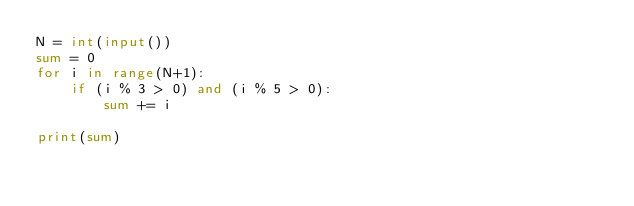<code> <loc_0><loc_0><loc_500><loc_500><_Python_>N = int(input())
sum = 0
for i in range(N+1):
    if (i % 3 > 0) and (i % 5 > 0):
        sum += i

print(sum)</code> 